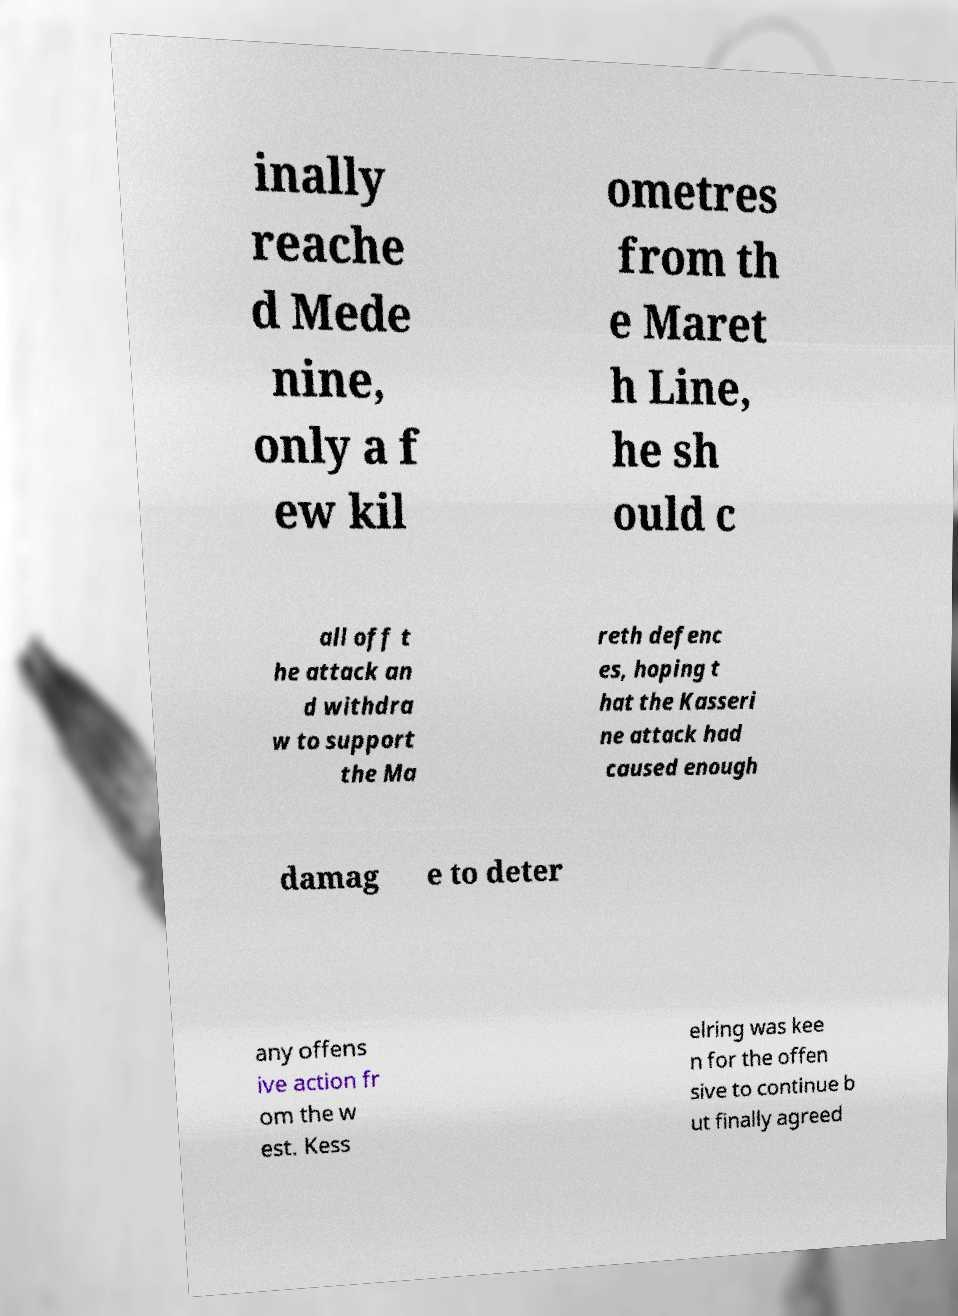For documentation purposes, I need the text within this image transcribed. Could you provide that? inally reache d Mede nine, only a f ew kil ometres from th e Maret h Line, he sh ould c all off t he attack an d withdra w to support the Ma reth defenc es, hoping t hat the Kasseri ne attack had caused enough damag e to deter any offens ive action fr om the w est. Kess elring was kee n for the offen sive to continue b ut finally agreed 